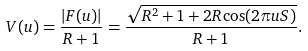<formula> <loc_0><loc_0><loc_500><loc_500>V ( u ) = \frac { | F ( u ) | } { R + 1 } = \frac { \sqrt { R ^ { 2 } + 1 + 2 R \cos ( 2 \pi u S ) } } { R + 1 } .</formula> 